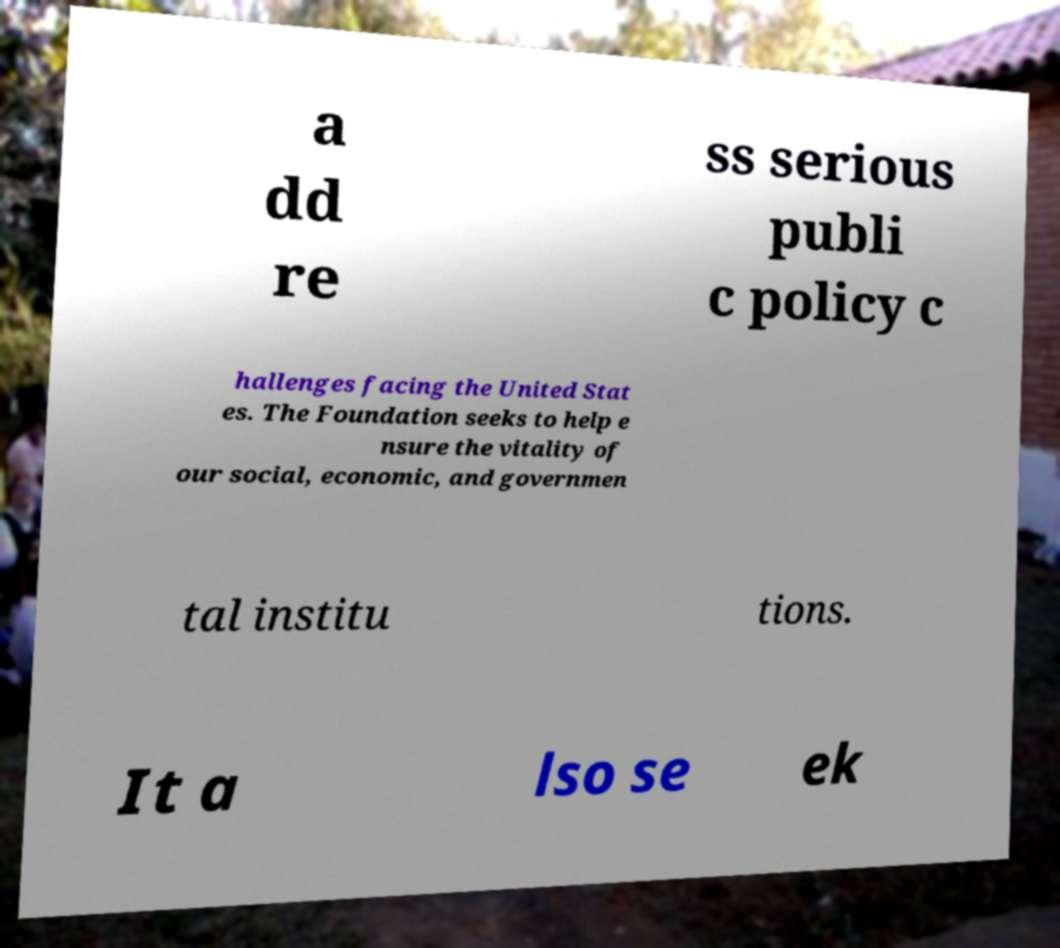Can you accurately transcribe the text from the provided image for me? a dd re ss serious publi c policy c hallenges facing the United Stat es. The Foundation seeks to help e nsure the vitality of our social, economic, and governmen tal institu tions. It a lso se ek 